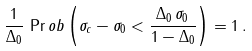Convert formula to latex. <formula><loc_0><loc_0><loc_500><loc_500>\frac { 1 } { \Delta _ { 0 } } \, \Pr o b \left ( \sigma _ { c } - \sigma _ { 0 } < \frac { \Delta _ { 0 } \, \sigma _ { 0 } } { 1 - \Delta _ { 0 } } \right ) = 1 \, .</formula> 